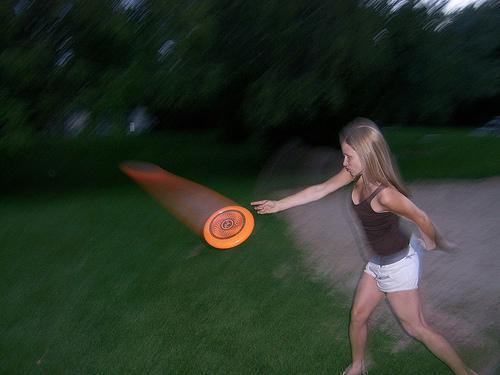How many people are visible?
Give a very brief answer. 1. 